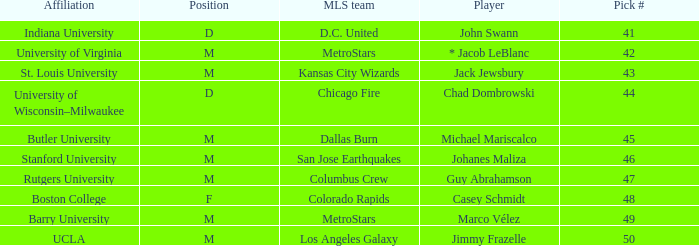What is the position of the Colorado Rapids team? F. 